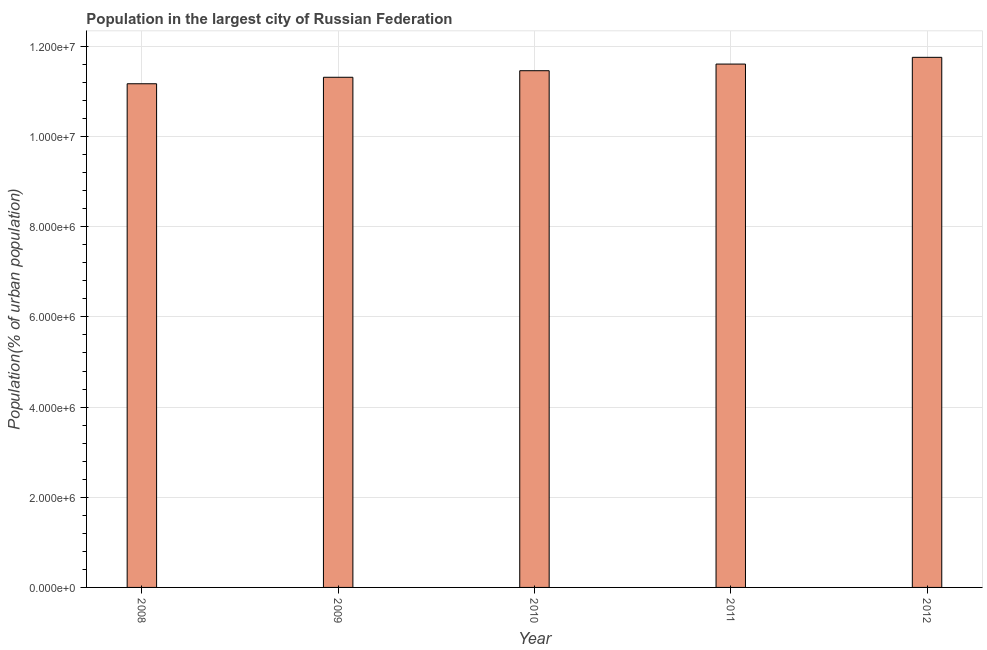Does the graph contain any zero values?
Your answer should be very brief. No. What is the title of the graph?
Offer a terse response. Population in the largest city of Russian Federation. What is the label or title of the Y-axis?
Your answer should be compact. Population(% of urban population). What is the population in largest city in 2010?
Offer a very short reply. 1.15e+07. Across all years, what is the maximum population in largest city?
Provide a short and direct response. 1.18e+07. Across all years, what is the minimum population in largest city?
Ensure brevity in your answer.  1.12e+07. In which year was the population in largest city maximum?
Keep it short and to the point. 2012. In which year was the population in largest city minimum?
Ensure brevity in your answer.  2008. What is the sum of the population in largest city?
Your response must be concise. 5.73e+07. What is the difference between the population in largest city in 2008 and 2011?
Your answer should be compact. -4.37e+05. What is the average population in largest city per year?
Your answer should be very brief. 1.15e+07. What is the median population in largest city?
Provide a short and direct response. 1.15e+07. Do a majority of the years between 2008 and 2009 (inclusive) have population in largest city greater than 6000000 %?
Ensure brevity in your answer.  Yes. What is the ratio of the population in largest city in 2008 to that in 2011?
Make the answer very short. 0.96. Is the population in largest city in 2008 less than that in 2011?
Your answer should be very brief. Yes. What is the difference between the highest and the second highest population in largest city?
Make the answer very short. 1.49e+05. Is the sum of the population in largest city in 2008 and 2009 greater than the maximum population in largest city across all years?
Keep it short and to the point. Yes. What is the difference between the highest and the lowest population in largest city?
Your answer should be very brief. 5.86e+05. In how many years, is the population in largest city greater than the average population in largest city taken over all years?
Make the answer very short. 2. What is the difference between two consecutive major ticks on the Y-axis?
Your answer should be compact. 2.00e+06. What is the Population(% of urban population) of 2008?
Your answer should be very brief. 1.12e+07. What is the Population(% of urban population) in 2009?
Your answer should be very brief. 1.13e+07. What is the Population(% of urban population) of 2010?
Give a very brief answer. 1.15e+07. What is the Population(% of urban population) in 2011?
Offer a terse response. 1.16e+07. What is the Population(% of urban population) in 2012?
Your response must be concise. 1.18e+07. What is the difference between the Population(% of urban population) in 2008 and 2009?
Make the answer very short. -1.44e+05. What is the difference between the Population(% of urban population) in 2008 and 2010?
Ensure brevity in your answer.  -2.89e+05. What is the difference between the Population(% of urban population) in 2008 and 2011?
Make the answer very short. -4.37e+05. What is the difference between the Population(% of urban population) in 2008 and 2012?
Your response must be concise. -5.86e+05. What is the difference between the Population(% of urban population) in 2009 and 2010?
Make the answer very short. -1.46e+05. What is the difference between the Population(% of urban population) in 2009 and 2011?
Ensure brevity in your answer.  -2.93e+05. What is the difference between the Population(% of urban population) in 2009 and 2012?
Provide a succinct answer. -4.43e+05. What is the difference between the Population(% of urban population) in 2010 and 2011?
Your response must be concise. -1.47e+05. What is the difference between the Population(% of urban population) in 2010 and 2012?
Ensure brevity in your answer.  -2.97e+05. What is the difference between the Population(% of urban population) in 2011 and 2012?
Your answer should be compact. -1.49e+05. What is the ratio of the Population(% of urban population) in 2008 to that in 2010?
Offer a terse response. 0.97. What is the ratio of the Population(% of urban population) in 2008 to that in 2011?
Ensure brevity in your answer.  0.96. What is the ratio of the Population(% of urban population) in 2008 to that in 2012?
Ensure brevity in your answer.  0.95. What is the ratio of the Population(% of urban population) in 2009 to that in 2010?
Your response must be concise. 0.99. What is the ratio of the Population(% of urban population) in 2009 to that in 2011?
Offer a terse response. 0.97. What is the ratio of the Population(% of urban population) in 2009 to that in 2012?
Your answer should be compact. 0.96. What is the ratio of the Population(% of urban population) in 2010 to that in 2011?
Your answer should be compact. 0.99. What is the ratio of the Population(% of urban population) in 2010 to that in 2012?
Your answer should be compact. 0.97. What is the ratio of the Population(% of urban population) in 2011 to that in 2012?
Provide a short and direct response. 0.99. 